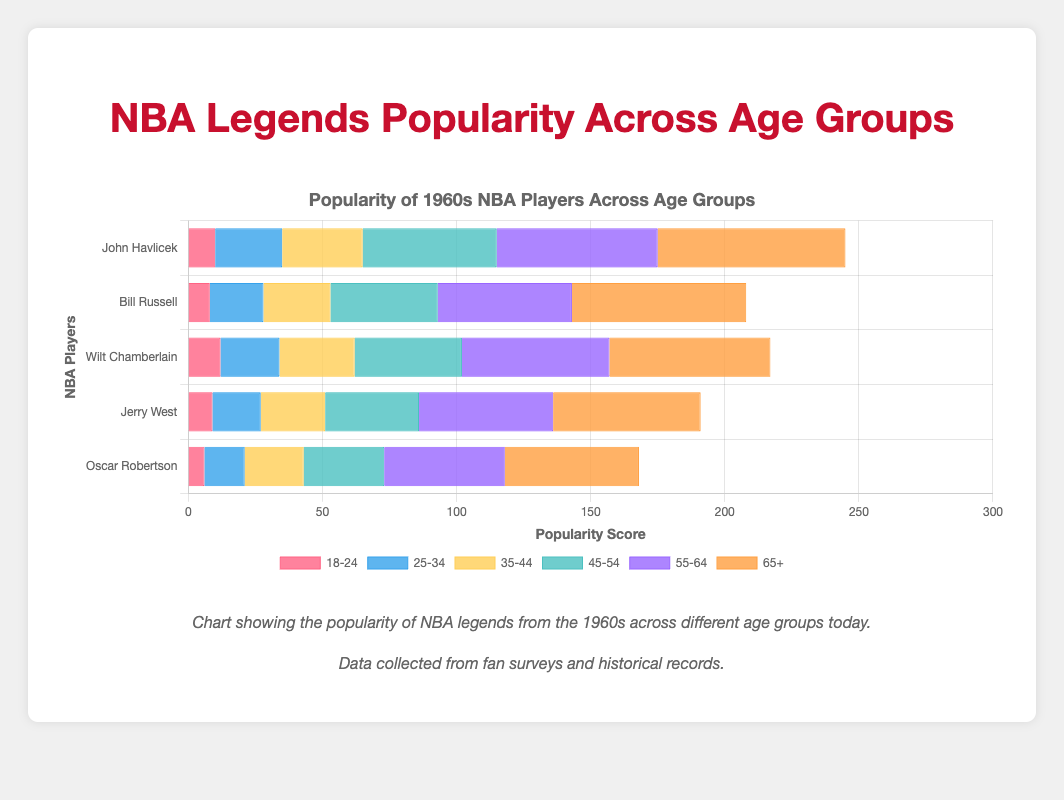Which NBA player is the most popular in the 65+ age group? Looking at the bars representing the 65+ age group, John Havlicek's bar is the longest, indicating he has the highest popularity in this age group.
Answer: John Havlicek Comparing John Havlicek and Wilt Chamberlain, which player has a higher popularity in the 45-54 age group? Looking at the bars for each player in the 45-54 age group, John Havlicek has a score of 50 while Wilt Chamberlain has a score of 40, meaning Havlicek is more popular in this age group.
Answer: John Havlicek Which player's 18-24 age group bar has the highest value? The longest bar for the 18-24 age group is for Wilt Chamberlain, indicating he is the most popular among 18-24-year-olds.
Answer: Wilt Chamberlain What is the combined popularity of John Havlicek across all age groups? Adding John Havlicek's popularity scores: 10 (18-24) + 25 (25-34) + 30 (35-44) + 50 (45-54) + 60 (55-64) + 70 (65+) = 245.
Answer: 245 How does Jerry West's popularity in the 55-64 age group compare to Oscar Robertson's? Looking at the bars for the 55-64 age group, Jerry West has a score of 50 while Oscar Robertson has a score of 45, meaning Jerry West is more popular in this age group.
Answer: Jerry West Which age group shows the largest difference in popularity between Bill Russell and John Havlicek? What is the difference? The differences for each age group are: 18-24: 2, 25-34: 5, 35-44: 5, 45-54: 10, 55-64: 10, 65+: 5. The largest difference is in the 45-54 and 55-64 age groups with a value of 10.
Answer: 10 What age group has the smallest popularity score for Oscar Robertson? The smallest bar for Oscar Robertson is in the 18-24 age group with a score of 6.
Answer: 18-24 What is the average popularity score of Bill Russell across all age groups? Adding Bill Russell's popularity scores: 8 (18-24) + 20 (25-34) + 25 (35-44) + 40 (45-54) + 50 (55-64) + 65 (65+) = 208. Average = 208/6 ≈ 34.67.
Answer: 34.67 How does the total combined popularity of Jerry West compare to Wilt Chamberlain? Adding the scores for Jerry West: 9 + 18 + 24 + 35 + 50 + 55 = 191. Adding the scores for Wilt Chamberlain: 12 + 22 + 28 + 40 + 55 + 60 = 217. Wilt Chamberlain has a higher total combined popularity.
Answer: Wilt Chamberlain Which player's popularity is closest in the 35-44 age group to their popularity in the 45-54 age group? For each player, the differences are:
- John Havlicek: 50 - 30 = 20
- Bill Russell: 40 - 25 = 15
- Wilt Chamberlain: 40 - 28 = 12
- Jerry West: 35 - 24 = 11
- Oscar Robertson: 30 - 22 = 8
The closest values are for Oscar Robertson with a difference of 8.
Answer: Oscar Robertson 